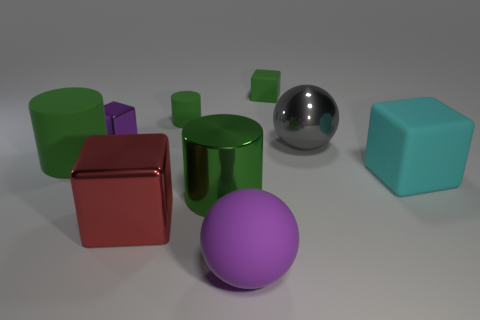How many cyan spheres are there?
Make the answer very short. 0. Are there any big gray spheres made of the same material as the tiny purple block?
Provide a short and direct response. Yes. The shiny cube that is the same color as the matte ball is what size?
Offer a terse response. Small. There is a green cylinder in front of the big cyan matte object; does it have the same size as the purple object behind the big matte block?
Offer a very short reply. No. How big is the shiny object behind the large gray metallic thing?
Make the answer very short. Small. Are there any other matte cylinders of the same color as the small cylinder?
Offer a terse response. Yes. Are there any purple things that are behind the big green thing that is to the right of the large red object?
Give a very brief answer. Yes. There is a rubber sphere; is it the same size as the metallic thing that is behind the big gray shiny thing?
Provide a short and direct response. No. There is a big block to the left of the matte thing in front of the big cyan thing; are there any big purple spheres left of it?
Offer a terse response. No. There is a large sphere that is in front of the cyan matte thing; what is its material?
Offer a very short reply. Rubber. 